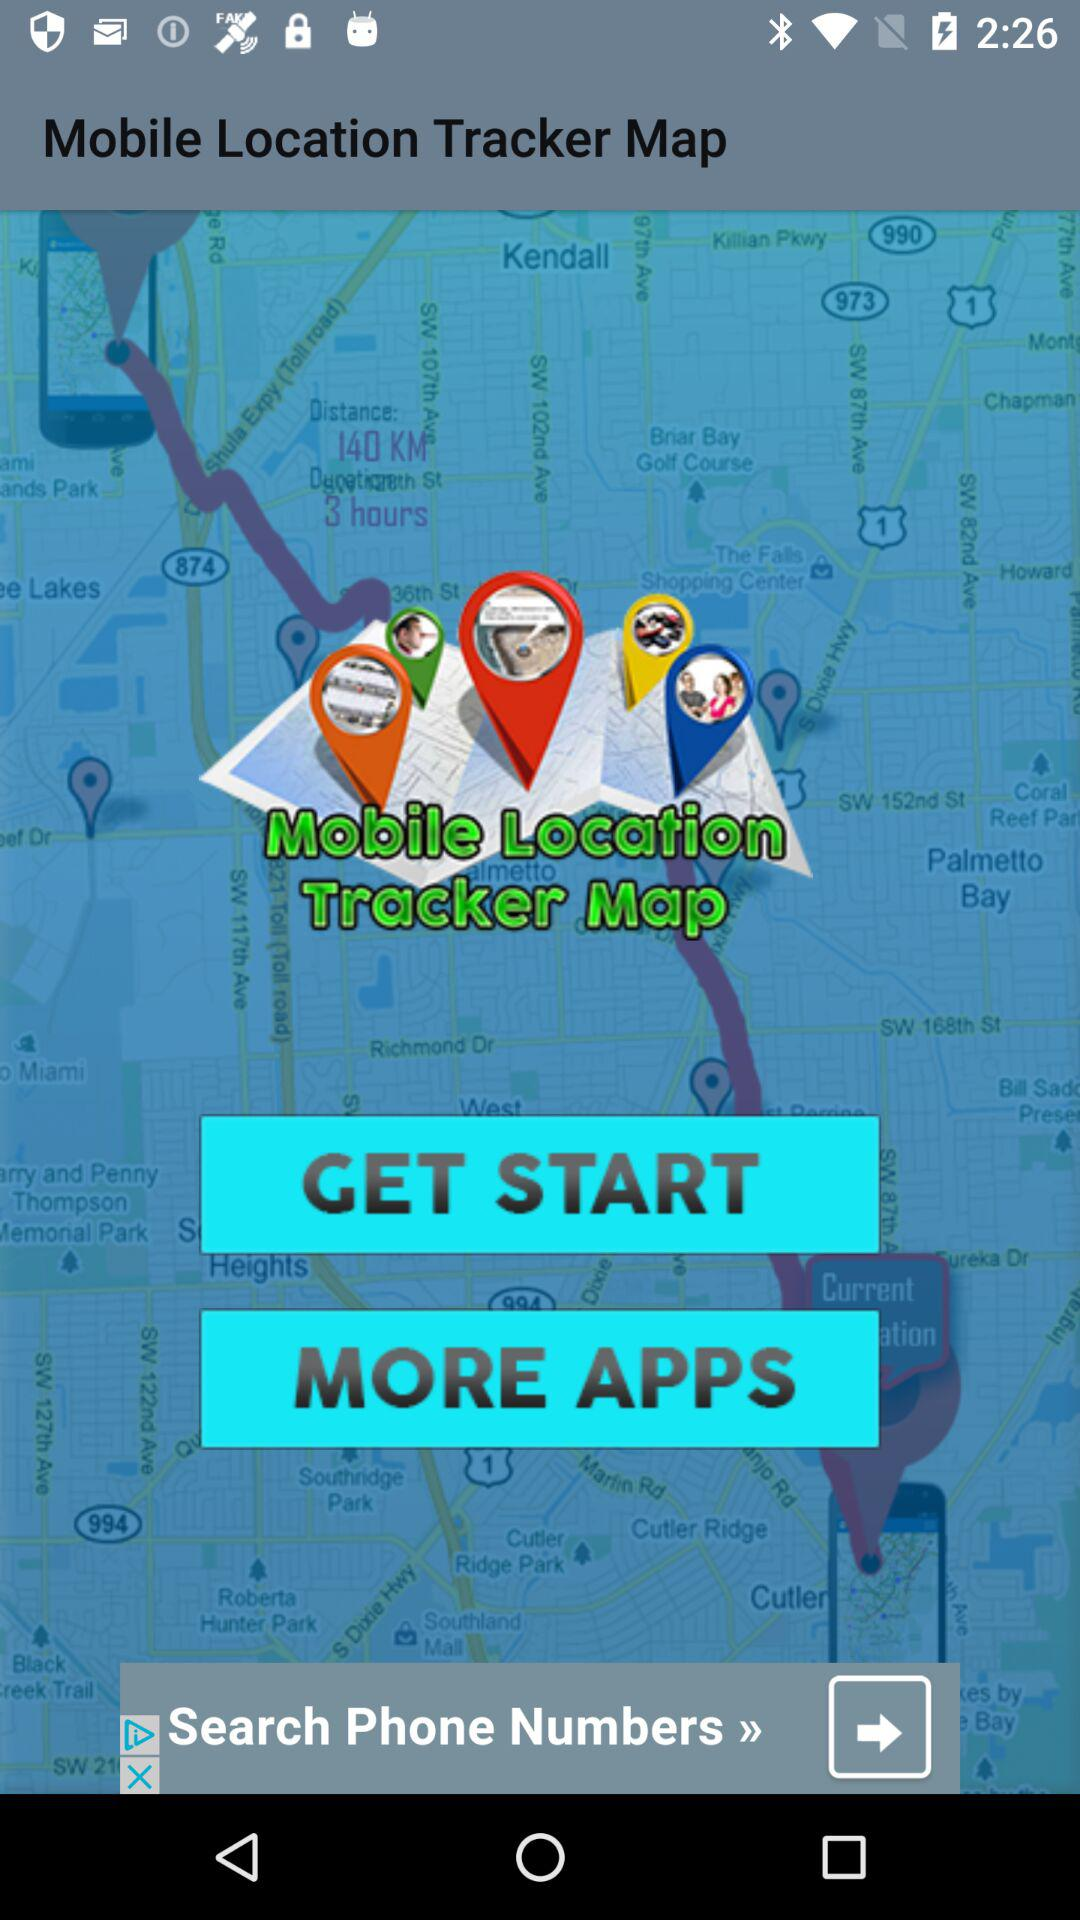What is the application name? The application name is "Mobile Location Tracker Map". 